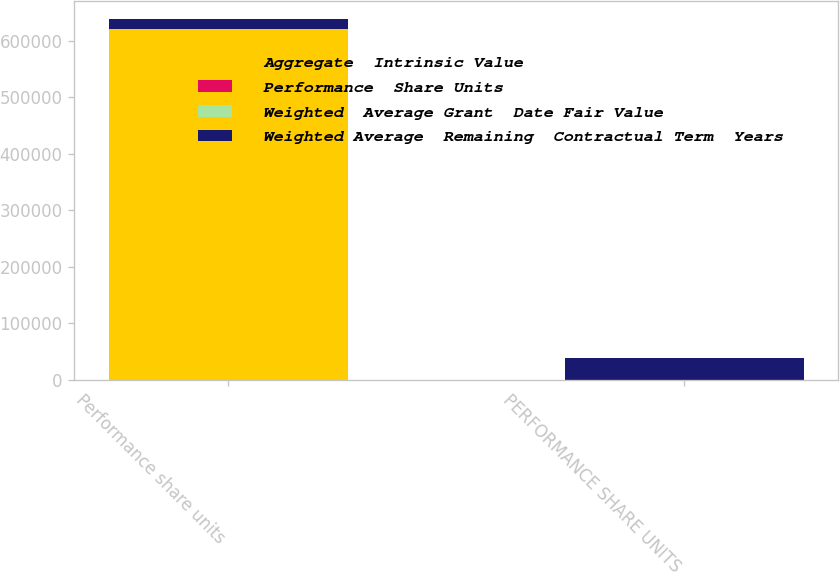Convert chart to OTSL. <chart><loc_0><loc_0><loc_500><loc_500><stacked_bar_chart><ecel><fcel>Performance share units<fcel>PERFORMANCE SHARE UNITS<nl><fcel>Aggregate  Intrinsic Value<fcel>620898<fcel>25.65<nl><fcel>Performance  Share Units<fcel>20.39<fcel>25.65<nl><fcel>Weighted  Average Grant  Date Fair Value<fcel>2.2<fcel>1.61<nl><fcel>Weighted Average  Remaining  Contractual Term  Years<fcel>18347<fcel>39107<nl></chart> 